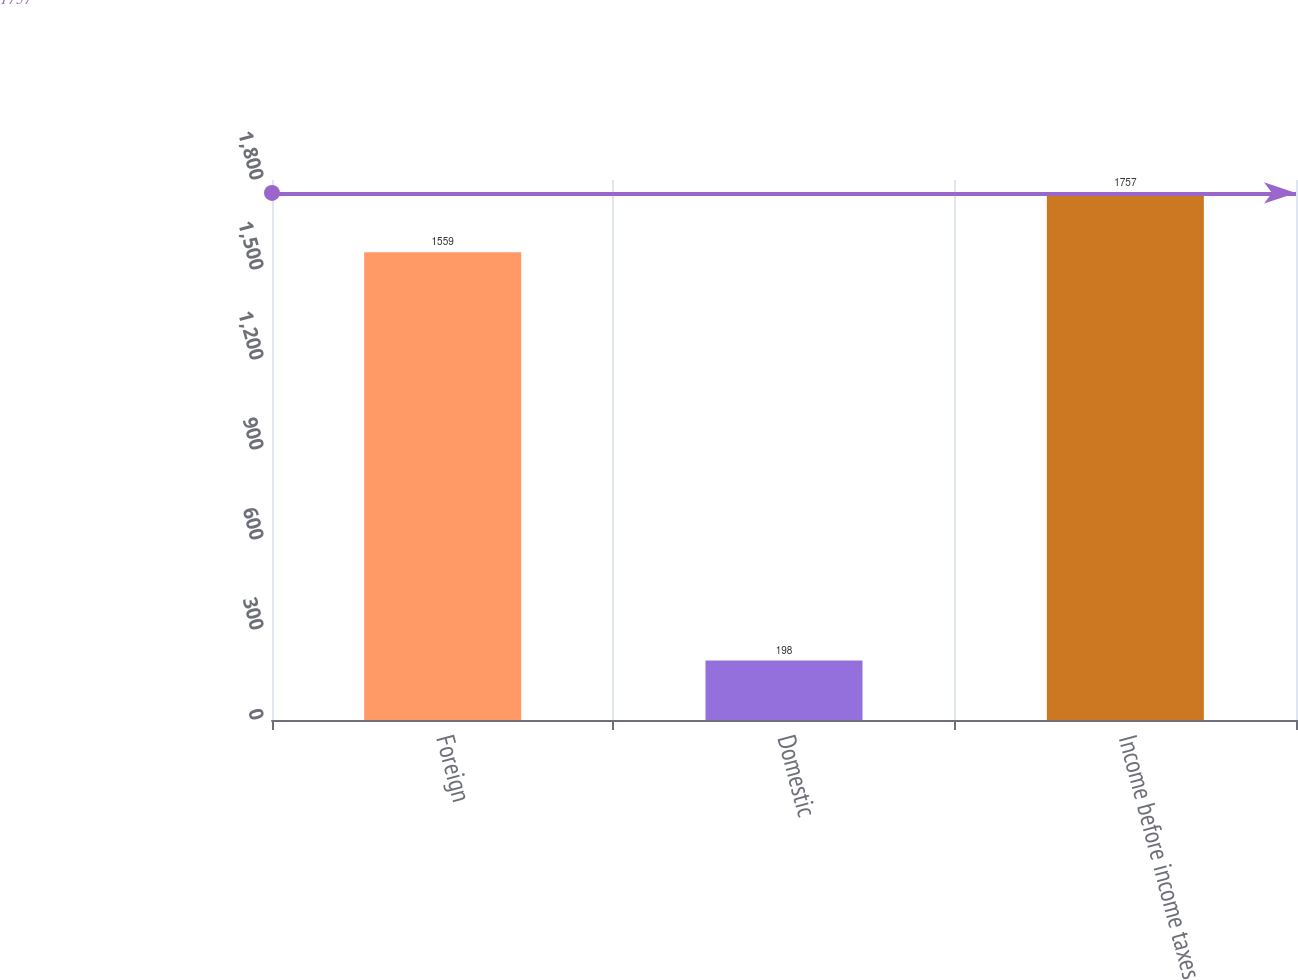Convert chart. <chart><loc_0><loc_0><loc_500><loc_500><bar_chart><fcel>Foreign<fcel>Domestic<fcel>Income before income taxes<nl><fcel>1559<fcel>198<fcel>1757<nl></chart> 